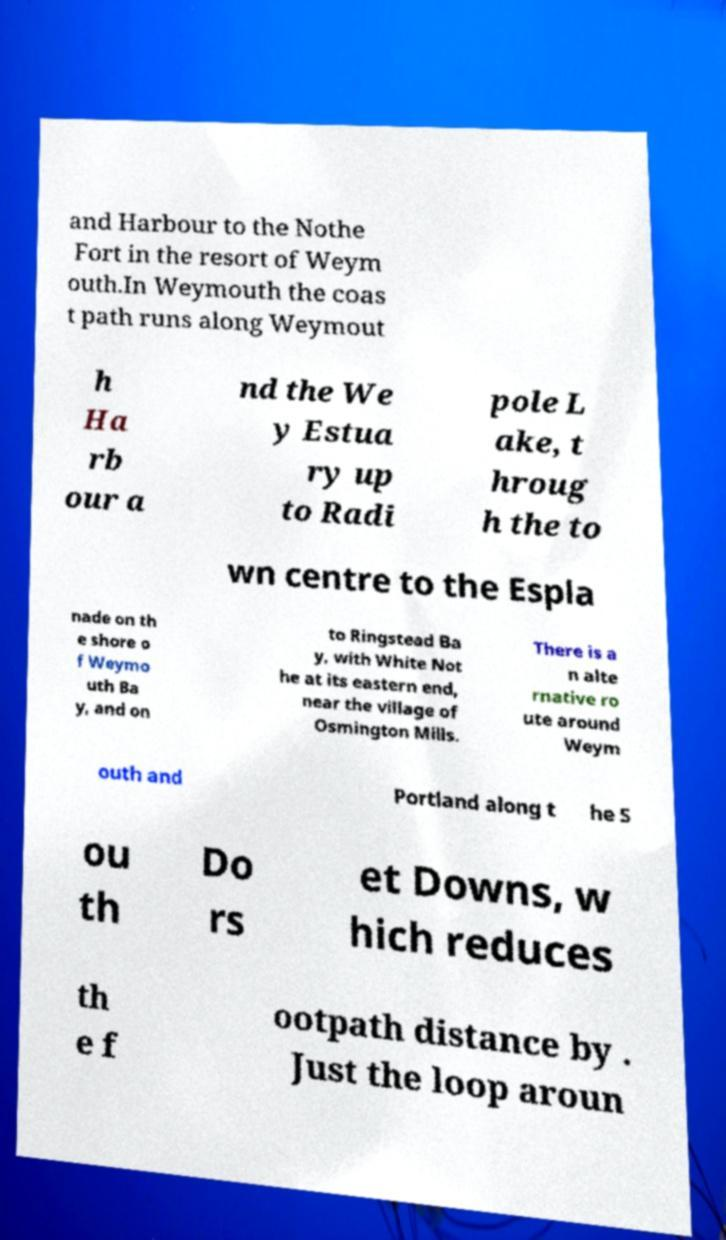There's text embedded in this image that I need extracted. Can you transcribe it verbatim? and Harbour to the Nothe Fort in the resort of Weym outh.In Weymouth the coas t path runs along Weymout h Ha rb our a nd the We y Estua ry up to Radi pole L ake, t hroug h the to wn centre to the Espla nade on th e shore o f Weymo uth Ba y, and on to Ringstead Ba y, with White Not he at its eastern end, near the village of Osmington Mills. There is a n alte rnative ro ute around Weym outh and Portland along t he S ou th Do rs et Downs, w hich reduces th e f ootpath distance by . Just the loop aroun 